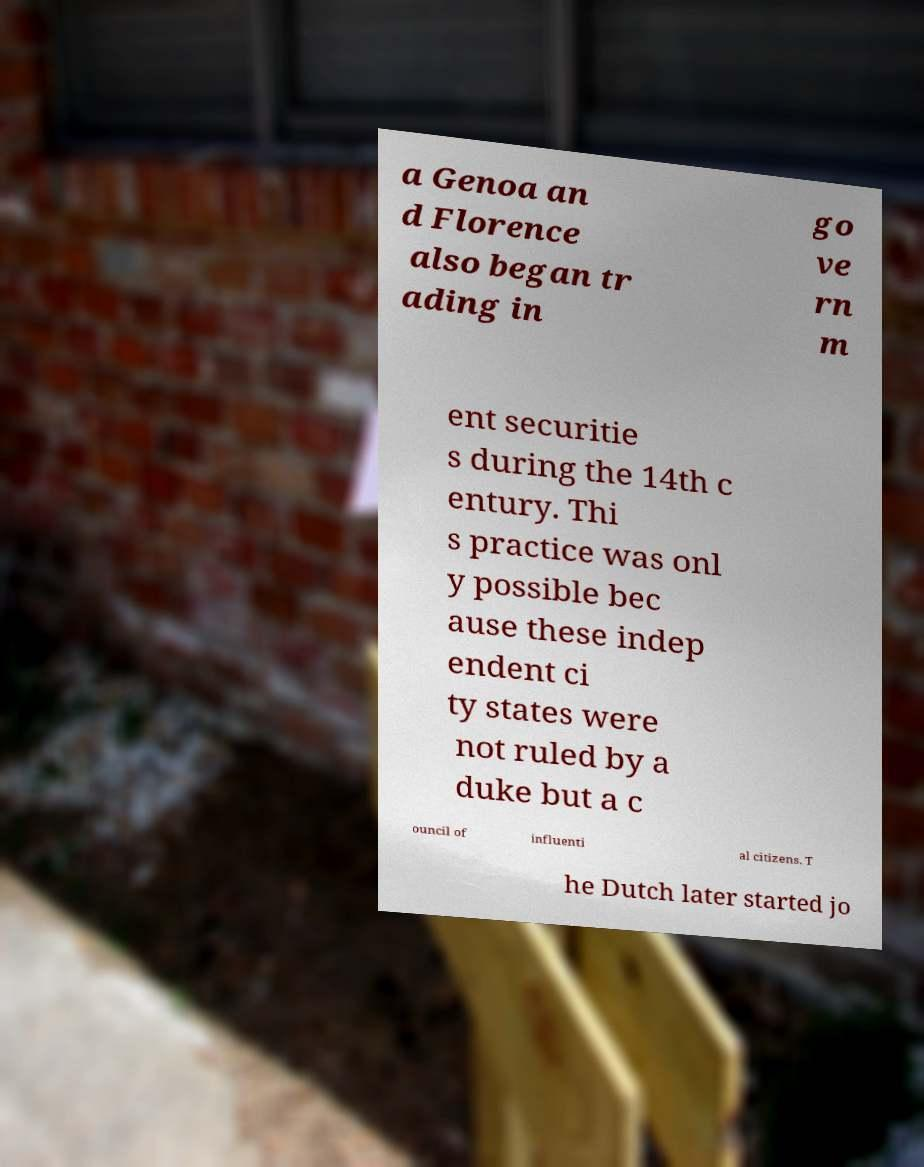There's text embedded in this image that I need extracted. Can you transcribe it verbatim? a Genoa an d Florence also began tr ading in go ve rn m ent securitie s during the 14th c entury. Thi s practice was onl y possible bec ause these indep endent ci ty states were not ruled by a duke but a c ouncil of influenti al citizens. T he Dutch later started jo 